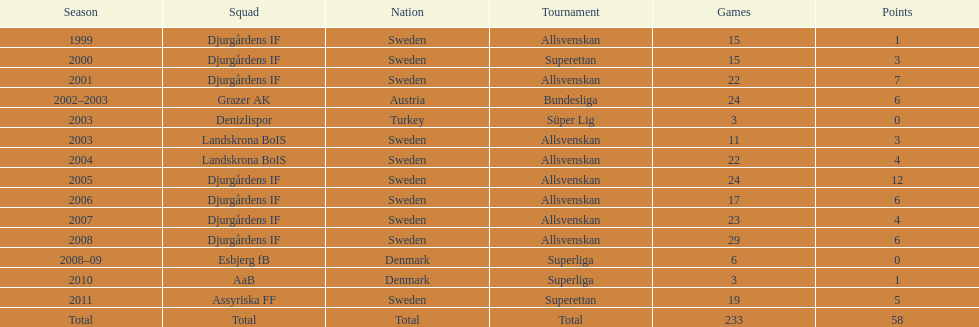How many matches did jones kusi-asare play in in his first season? 15. 